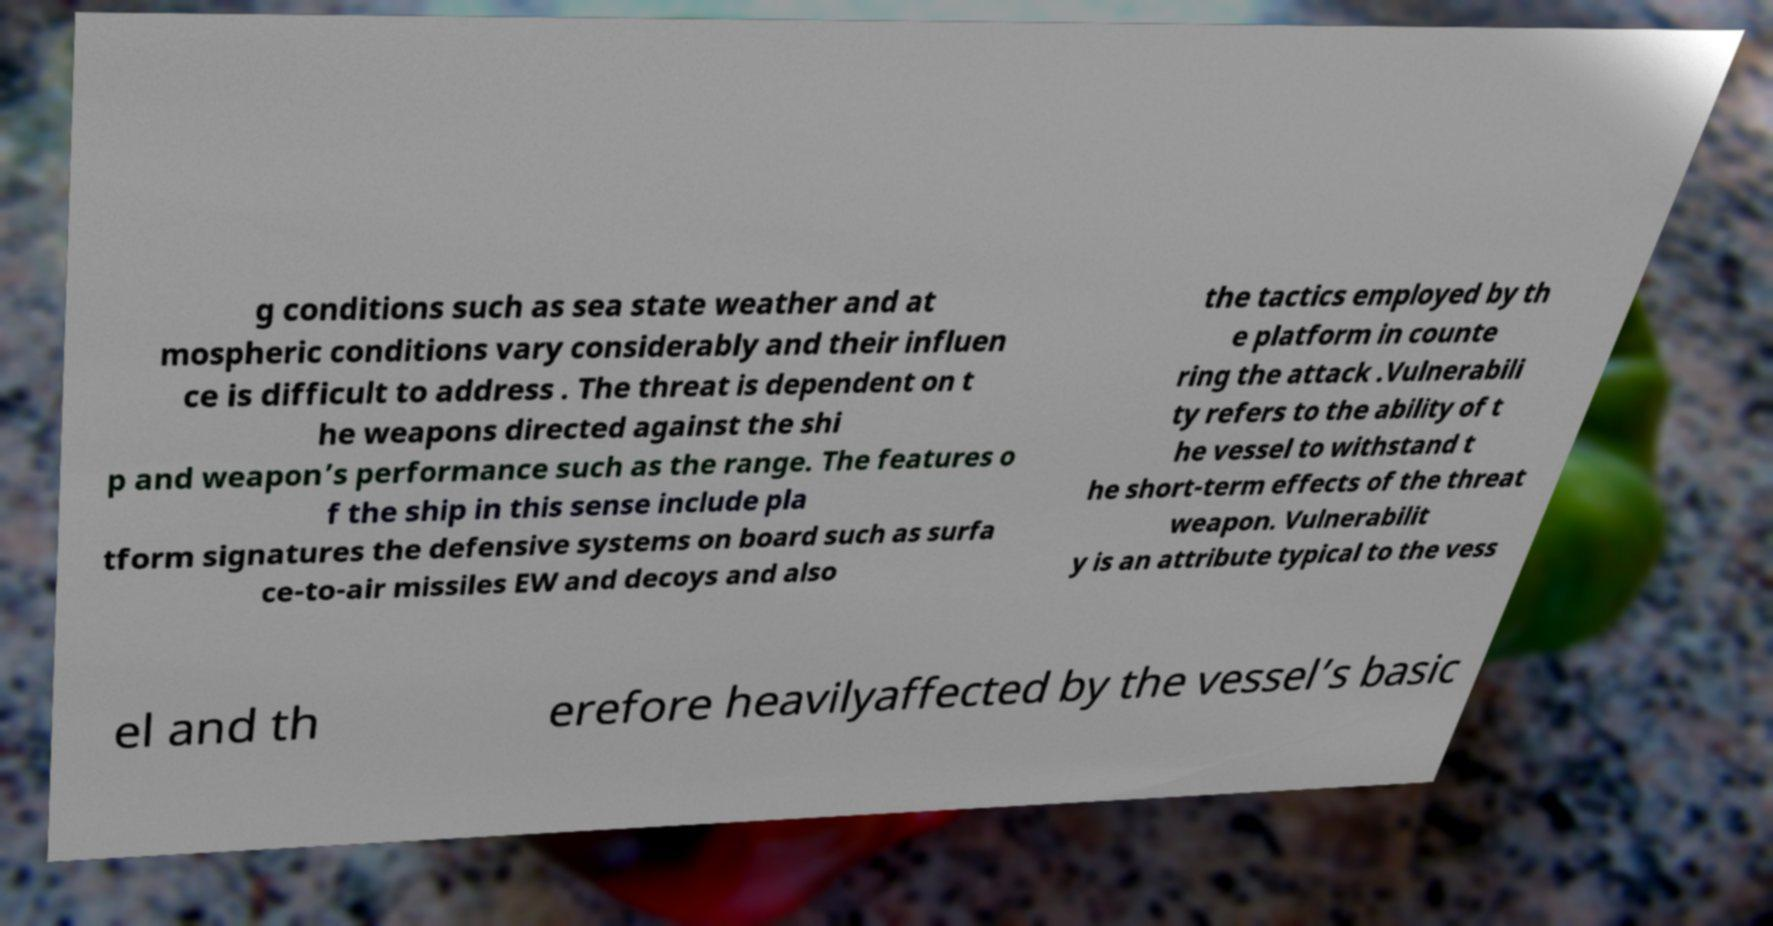Could you extract and type out the text from this image? g conditions such as sea state weather and at mospheric conditions vary considerably and their influen ce is difficult to address . The threat is dependent on t he weapons directed against the shi p and weapon’s performance such as the range. The features o f the ship in this sense include pla tform signatures the defensive systems on board such as surfa ce-to-air missiles EW and decoys and also the tactics employed by th e platform in counte ring the attack .Vulnerabili ty refers to the ability of t he vessel to withstand t he short-term effects of the threat weapon. Vulnerabilit y is an attribute typical to the vess el and th erefore heavilyaffected by the vessel’s basic 